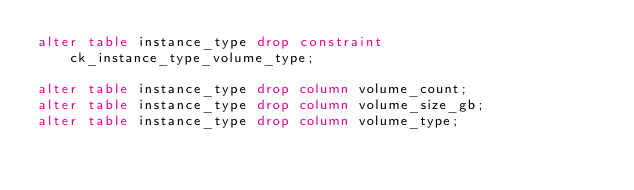<code> <loc_0><loc_0><loc_500><loc_500><_SQL_>alter table instance_type drop constraint ck_instance_type_volume_type;

alter table instance_type drop column volume_count;
alter table instance_type drop column volume_size_gb;
alter table instance_type drop column volume_type;
</code> 